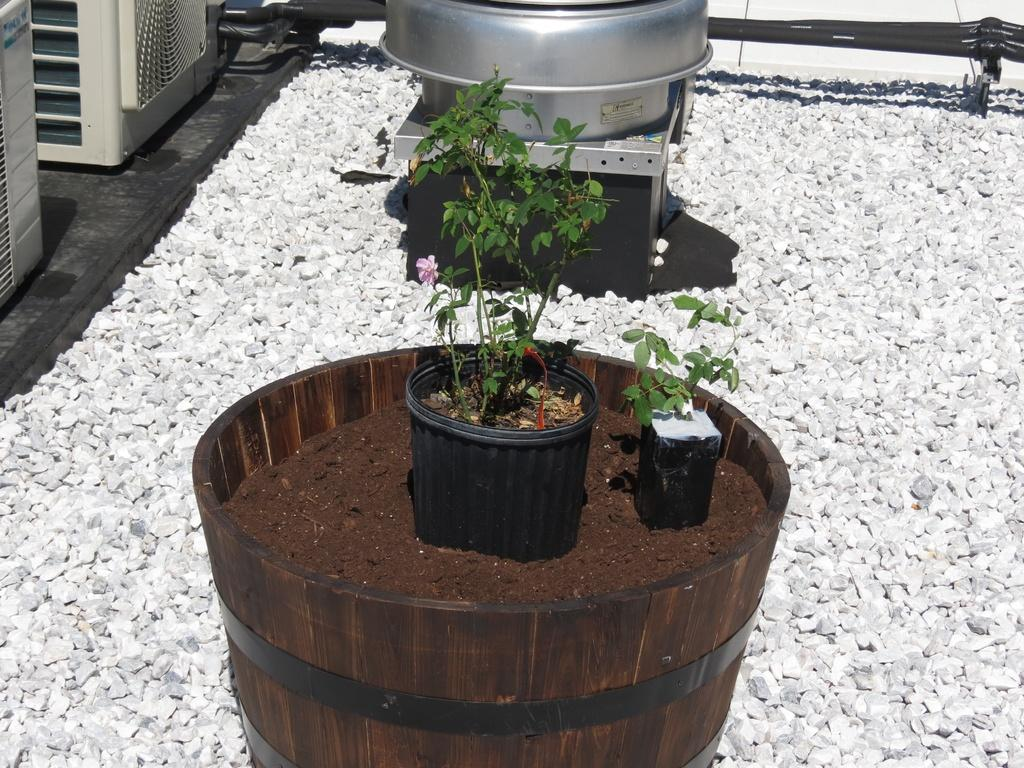What is the main subject in the center of the image? There are plants in the center of the image. What can be seen at the top side of the image? There is a container at the top side of the image. What material is used for the floor in the image? The floor in the image is made of pebbles. How does the rabbit fall from the sky in the image? There is no rabbit present in the image, and therefore no falling rabbit can be observed. 